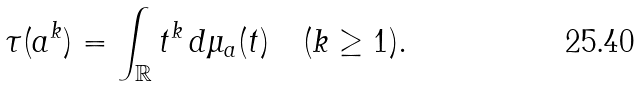Convert formula to latex. <formula><loc_0><loc_0><loc_500><loc_500>\tau ( a ^ { k } ) = \int _ { \mathbb { R } } t ^ { k } \, d \mu _ { a } ( t ) \quad ( k \geq 1 ) .</formula> 